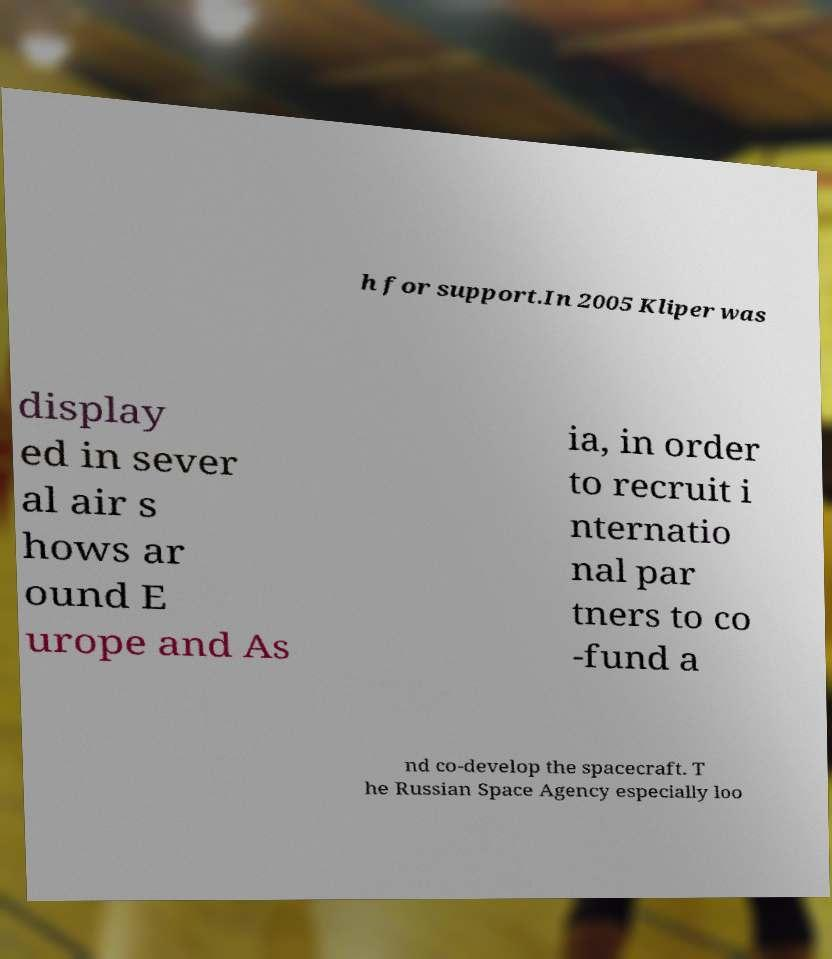For documentation purposes, I need the text within this image transcribed. Could you provide that? h for support.In 2005 Kliper was display ed in sever al air s hows ar ound E urope and As ia, in order to recruit i nternatio nal par tners to co -fund a nd co-develop the spacecraft. T he Russian Space Agency especially loo 